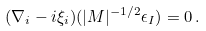<formula> <loc_0><loc_0><loc_500><loc_500>( \nabla _ { i } - i \xi _ { i } ) ( | M | ^ { - 1 / 2 } \epsilon _ { I } ) = 0 \, .</formula> 